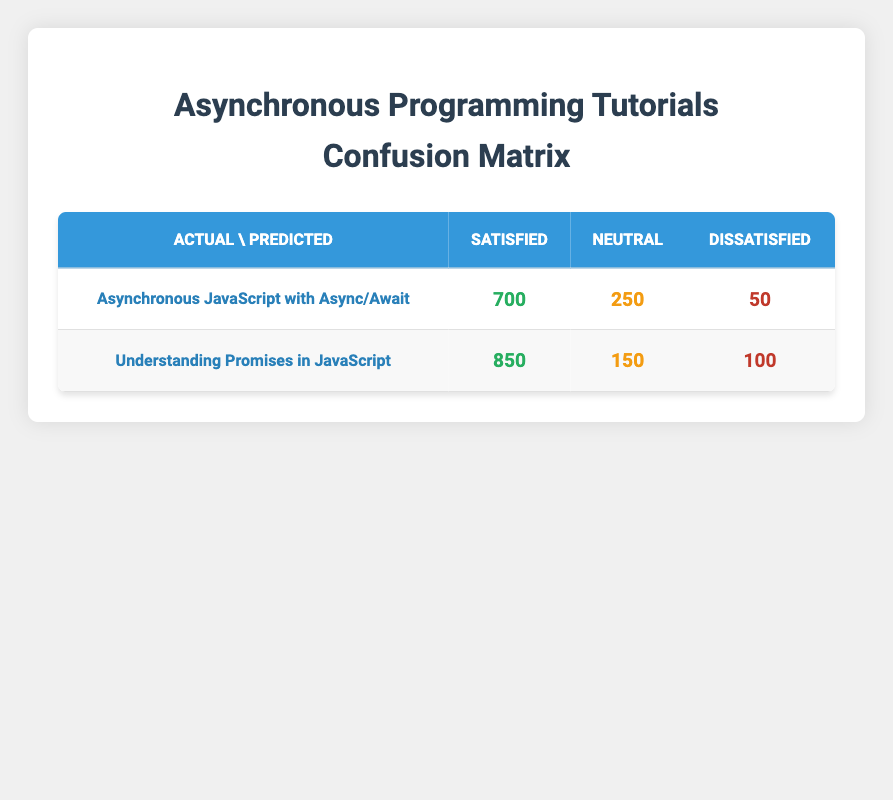What is the total number of users who were satisfied with the "Asynchronous JavaScript with Async/Await" tutorial? The table shows that for "Asynchronous JavaScript with Async/Await," the count of users who were satisfied is 700.
Answer: 700 What is the count of users who felt neutral about the "Understanding Promises in JavaScript" tutorial? According to the table, the count of users who felt neutral about this tutorial is 150.
Answer: 150 How many total users provided feedback for the "Asynchronous JavaScript with Async/Await" tutorial? To find the total, we add the counts of all ratings for this tutorial: 700 (satisfied) + 250 (neutral) + 50 (dissatisfied) = 1000.
Answer: 1000 What is the total number of satisfied users across both tutorials? For "Asynchronous JavaScript with Async/Await," there are 700 satisfied users, and for "Understanding Promises in JavaScript," there are 850 satisfied users. The total is 700 + 850 = 1550.
Answer: 1550 Did more users express dissatisfaction with the "Understanding Promises in JavaScript" tutorial compared to "Asynchronous JavaScript with Async/Await"? The table shows that 100 users were dissatisfied with "Understanding Promises in JavaScript" and 50 users were dissatisfied with "Asynchronous JavaScript with Async/Await." Thus, more users were dissatisfied with the first tutorial.
Answer: Yes What percentage of users who were predicted to be satisfied actually reported being satisfied for the "Understanding Promises in JavaScript" tutorial? From the table, 850 users were predicted as satisfied, and 850 actually reported being satisfied. The percentage is (850/850) * 100 = 100%.
Answer: 100% Which tutorial had a higher number of neutral responses compared to satisfied responses? The "Asynchronous JavaScript with Async/Await" tutorial had 250 neutral responses compared to 700 satisfied responses. The other tutorial had 150 neutral responses compared to 850 satisfied responses. Neither had higher neutral responses compared to satisfied ones.
Answer: Neither What is the average number of dissatisfied users across both tutorials? The "Asynchronous JavaScript with Async/Await" tutorial had 50 dissatisfied users, and "Understanding Promises in JavaScript" had 100 dissatisfied users. The average is (50 + 100) / 2 = 75.
Answer: 75 For the "Understanding Promises in JavaScript" tutorial, how many more users were satisfied than dissatisfied? The tutorial had 850 satisfied users and 100 dissatisfied users. The difference is 850 - 100 = 750.
Answer: 750 How many users in total rated the "Understanding Promises in JavaScript" tutorial? To find the total, we add the counts of all ratings: 850 (satisfied) + 150 (neutral) + 100 (dissatisfied) = 1100.
Answer: 1100 